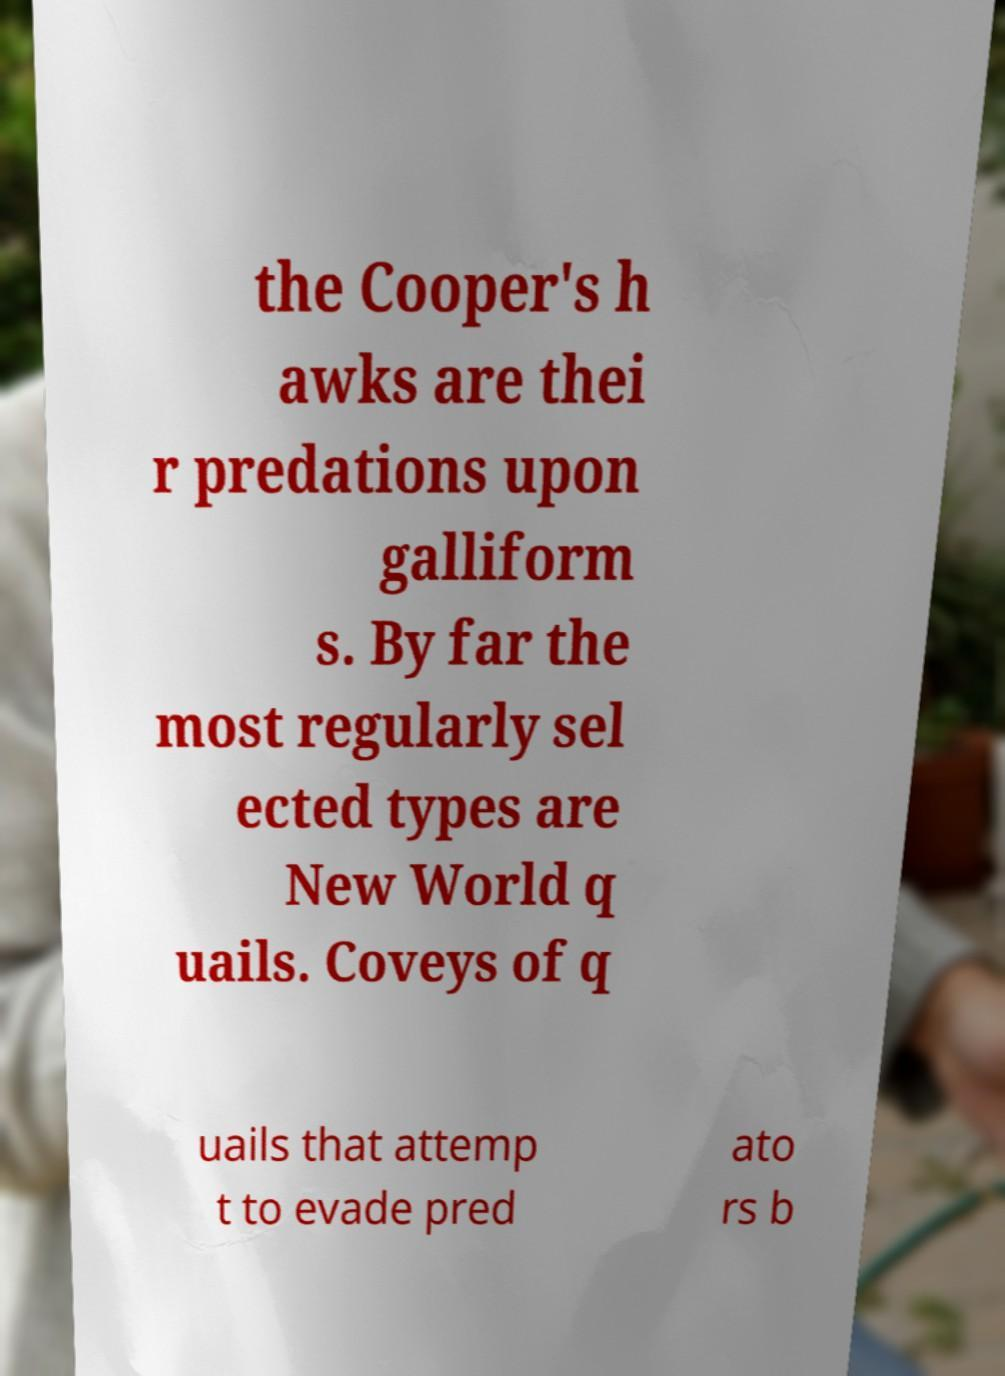There's text embedded in this image that I need extracted. Can you transcribe it verbatim? the Cooper's h awks are thei r predations upon galliform s. By far the most regularly sel ected types are New World q uails. Coveys of q uails that attemp t to evade pred ato rs b 